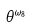Convert formula to latex. <formula><loc_0><loc_0><loc_500><loc_500>\theta ^ { \omega _ { 8 } }</formula> 